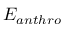<formula> <loc_0><loc_0><loc_500><loc_500>E _ { a n t h r o }</formula> 